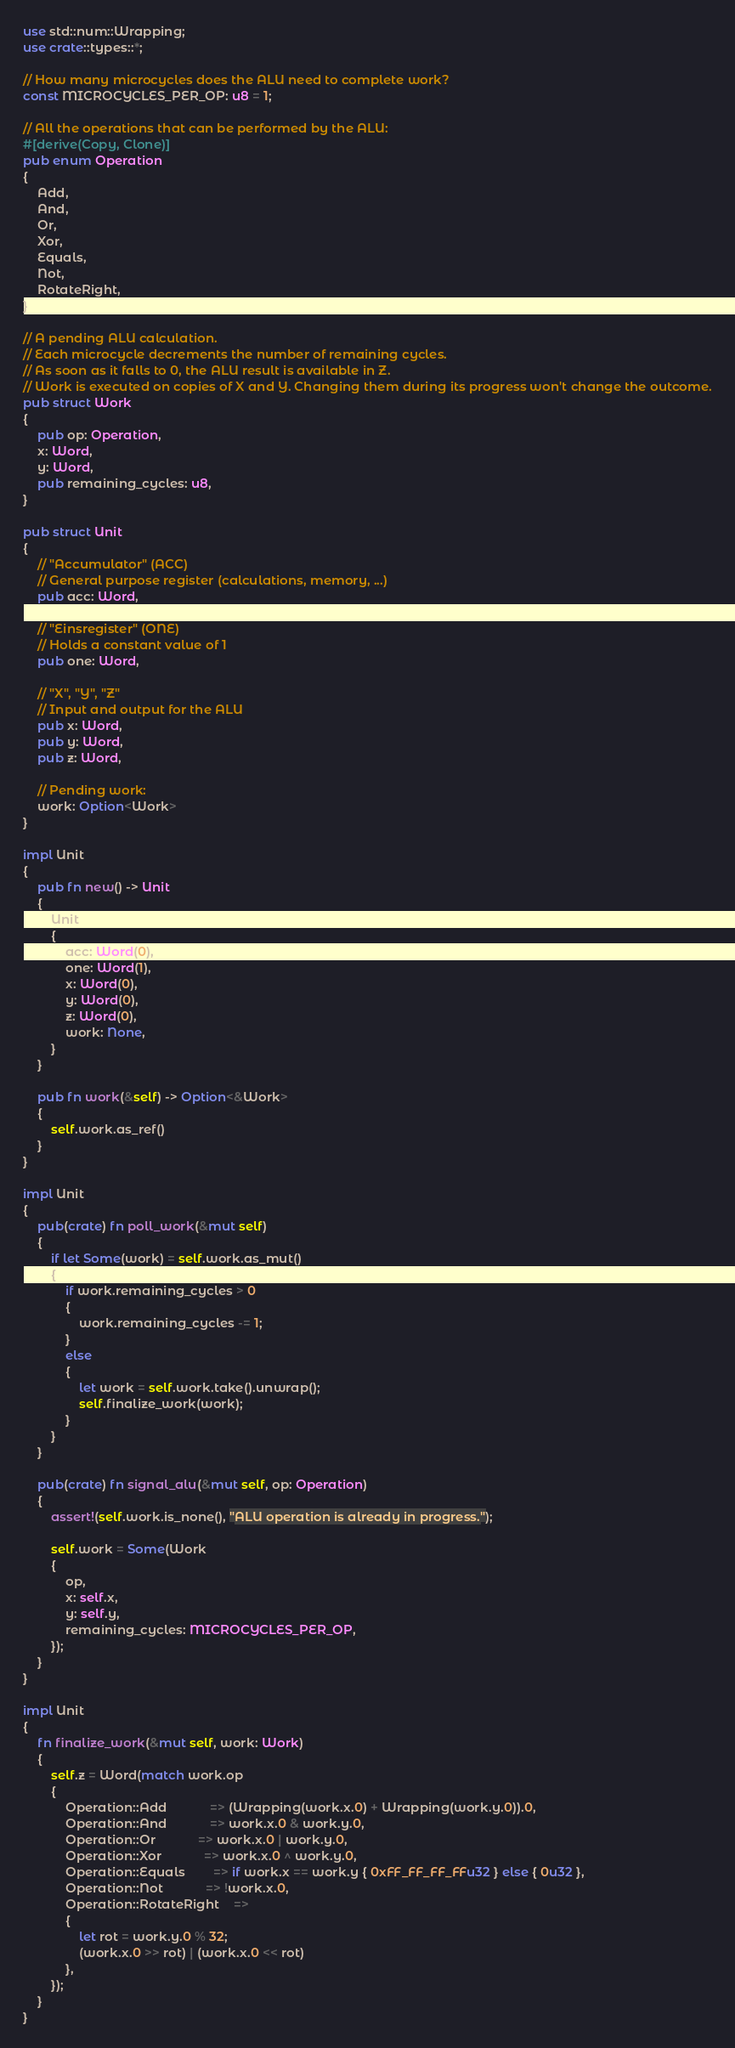Convert code to text. <code><loc_0><loc_0><loc_500><loc_500><_Rust_>use std::num::Wrapping;
use crate::types::*;

// How many microcycles does the ALU need to complete work?
const MICROCYCLES_PER_OP: u8 = 1;

// All the operations that can be performed by the ALU:
#[derive(Copy, Clone)]
pub enum Operation
{
	Add,
	And,
	Or,
	Xor,
	Equals,
	Not,
	RotateRight,
}

// A pending ALU calculation.
// Each microcycle decrements the number of remaining cycles.
// As soon as it falls to 0, the ALU result is available in Z.
// Work is executed on copies of X and Y. Changing them during its progress won't change the outcome.
pub struct Work
{
	pub op: Operation,
	x: Word,
	y: Word,
	pub remaining_cycles: u8,
}

pub struct Unit
{
	// "Accumulator" (ACC)
	// General purpose register (calculations, memory, ...)
	pub acc: Word,

	// "Einsregister" (ONE)
	// Holds a constant value of 1
	pub one: Word,

	// "X", "Y", "Z"
	// Input and output for the ALU
	pub x: Word,
	pub y: Word,
	pub z: Word,

	// Pending work:
	work: Option<Work>
}

impl Unit
{
	pub fn new() -> Unit
	{
		Unit
		{
			acc: Word(0),
			one: Word(1),
			x: Word(0),
			y: Word(0),
			z: Word(0),
			work: None,
		}
	}

	pub fn work(&self) -> Option<&Work>
	{
		self.work.as_ref()
	}
}

impl Unit
{
	pub(crate) fn poll_work(&mut self)
	{
		if let Some(work) = self.work.as_mut()
		{
			if work.remaining_cycles > 0
			{
				work.remaining_cycles -= 1;
			}
			else
			{
				let work = self.work.take().unwrap();
				self.finalize_work(work);
			}
		}
	}

	pub(crate) fn signal_alu(&mut self, op: Operation)
	{
		assert!(self.work.is_none(), "ALU operation is already in progress.");

		self.work = Some(Work
		{
			op,
			x: self.x,
			y: self.y,
			remaining_cycles: MICROCYCLES_PER_OP,
		});
	}
}

impl Unit
{
	fn finalize_work(&mut self, work: Work)
	{
		self.z = Word(match work.op
		{
			Operation::Add 			=> (Wrapping(work.x.0) + Wrapping(work.y.0)).0,
			Operation::And 			=> work.x.0 & work.y.0,
			Operation::Or 			=> work.x.0 | work.y.0,
			Operation::Xor 			=> work.x.0 ^ work.y.0,
			Operation::Equals 		=> if work.x == work.y { 0xFF_FF_FF_FFu32 } else { 0u32 },
			Operation::Not 			=> !work.x.0,
			Operation::RotateRight 	=>
			{
				let rot = work.y.0 % 32;
				(work.x.0 >> rot) | (work.x.0 << rot)
			},
		});
	}
}
</code> 